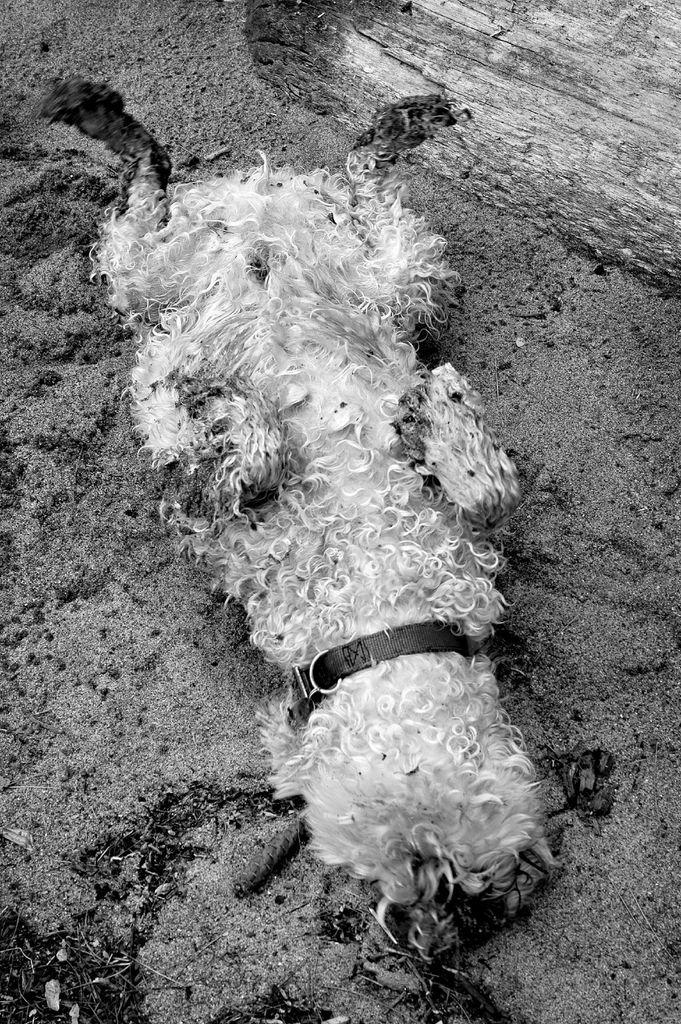What animal is present in the image? There is a dog in the image. Where is the dog located? The dog is on the ground. What can be seen in the background of the image? There appears to be tree bark in the background of the image. What type of roof material can be seen on the dog in the image? There is no roof material present in the image, as it features a dog on the ground with a tree bark background. 